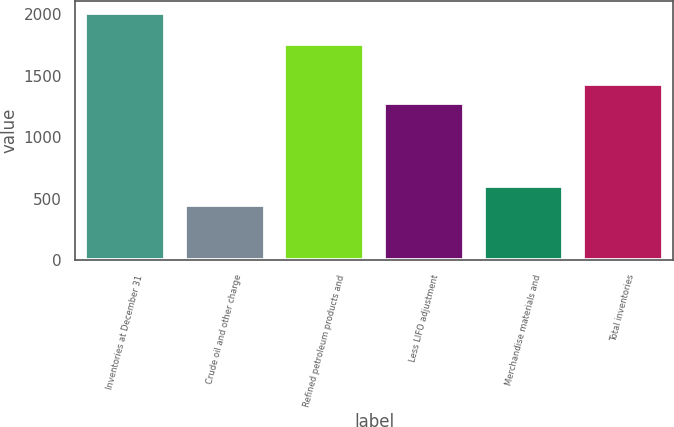<chart> <loc_0><loc_0><loc_500><loc_500><bar_chart><fcel>Inventories at December 31<fcel>Crude oil and other charge<fcel>Refined petroleum products and<fcel>Less LIFO adjustment<fcel>Merchandise materials and<fcel>Total inventories<nl><fcel>2011<fcel>451<fcel>1762<fcel>1276<fcel>607<fcel>1432<nl></chart> 